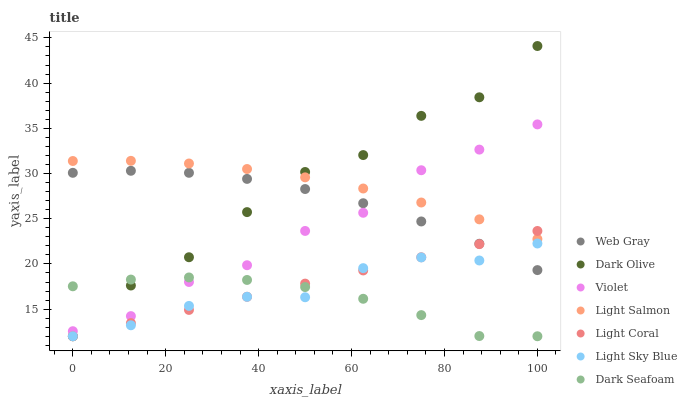Does Dark Seafoam have the minimum area under the curve?
Answer yes or no. Yes. Does Light Salmon have the maximum area under the curve?
Answer yes or no. Yes. Does Web Gray have the minimum area under the curve?
Answer yes or no. No. Does Web Gray have the maximum area under the curve?
Answer yes or no. No. Is Light Coral the smoothest?
Answer yes or no. Yes. Is Dark Olive the roughest?
Answer yes or no. Yes. Is Web Gray the smoothest?
Answer yes or no. No. Is Web Gray the roughest?
Answer yes or no. No. Does Dark Olive have the lowest value?
Answer yes or no. Yes. Does Web Gray have the lowest value?
Answer yes or no. No. Does Dark Olive have the highest value?
Answer yes or no. Yes. Does Web Gray have the highest value?
Answer yes or no. No. Is Web Gray less than Light Salmon?
Answer yes or no. Yes. Is Web Gray greater than Dark Seafoam?
Answer yes or no. Yes. Does Light Sky Blue intersect Web Gray?
Answer yes or no. Yes. Is Light Sky Blue less than Web Gray?
Answer yes or no. No. Is Light Sky Blue greater than Web Gray?
Answer yes or no. No. Does Web Gray intersect Light Salmon?
Answer yes or no. No. 